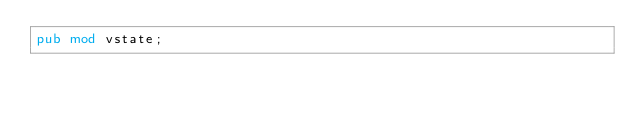Convert code to text. <code><loc_0><loc_0><loc_500><loc_500><_Rust_>pub mod vstate;
</code> 